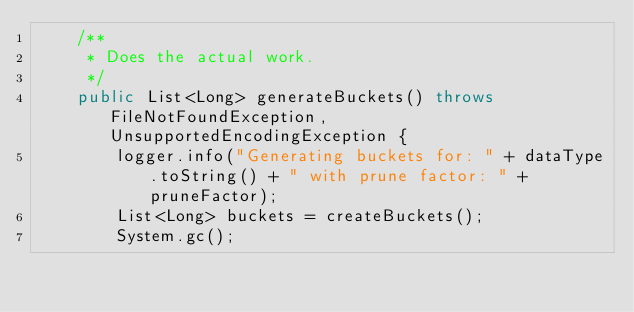Convert code to text. <code><loc_0><loc_0><loc_500><loc_500><_Java_>    /**
     * Does the actual work.
     */
    public List<Long> generateBuckets() throws FileNotFoundException, UnsupportedEncodingException {
        logger.info("Generating buckets for: " + dataType.toString() + " with prune factor: " + pruneFactor);
        List<Long> buckets = createBuckets();
        System.gc();</code> 